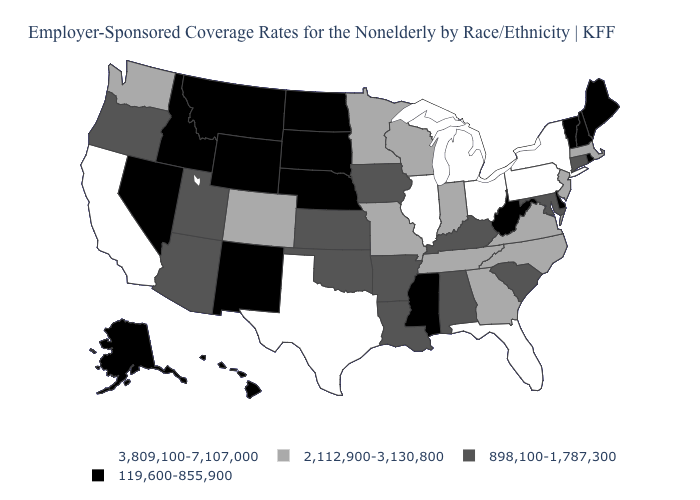Name the states that have a value in the range 3,809,100-7,107,000?
Answer briefly. California, Florida, Illinois, Michigan, New York, Ohio, Pennsylvania, Texas. What is the value of Texas?
Give a very brief answer. 3,809,100-7,107,000. What is the value of Texas?
Concise answer only. 3,809,100-7,107,000. Does Nebraska have the highest value in the MidWest?
Quick response, please. No. Name the states that have a value in the range 2,112,900-3,130,800?
Give a very brief answer. Colorado, Georgia, Indiana, Massachusetts, Minnesota, Missouri, New Jersey, North Carolina, Tennessee, Virginia, Washington, Wisconsin. What is the lowest value in states that border Wyoming?
Give a very brief answer. 119,600-855,900. Name the states that have a value in the range 2,112,900-3,130,800?
Concise answer only. Colorado, Georgia, Indiana, Massachusetts, Minnesota, Missouri, New Jersey, North Carolina, Tennessee, Virginia, Washington, Wisconsin. Which states have the lowest value in the USA?
Concise answer only. Alaska, Delaware, Hawaii, Idaho, Maine, Mississippi, Montana, Nebraska, Nevada, New Hampshire, New Mexico, North Dakota, Rhode Island, South Dakota, Vermont, West Virginia, Wyoming. How many symbols are there in the legend?
Answer briefly. 4. What is the lowest value in the USA?
Concise answer only. 119,600-855,900. Name the states that have a value in the range 3,809,100-7,107,000?
Be succinct. California, Florida, Illinois, Michigan, New York, Ohio, Pennsylvania, Texas. Which states have the lowest value in the USA?
Write a very short answer. Alaska, Delaware, Hawaii, Idaho, Maine, Mississippi, Montana, Nebraska, Nevada, New Hampshire, New Mexico, North Dakota, Rhode Island, South Dakota, Vermont, West Virginia, Wyoming. What is the lowest value in states that border Michigan?
Keep it brief. 2,112,900-3,130,800. Among the states that border Arizona , which have the lowest value?
Short answer required. Nevada, New Mexico. Does California have the highest value in the USA?
Be succinct. Yes. 